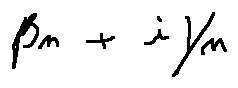<formula> <loc_0><loc_0><loc_500><loc_500>\beta _ { n } + i \gamma _ { n }</formula> 